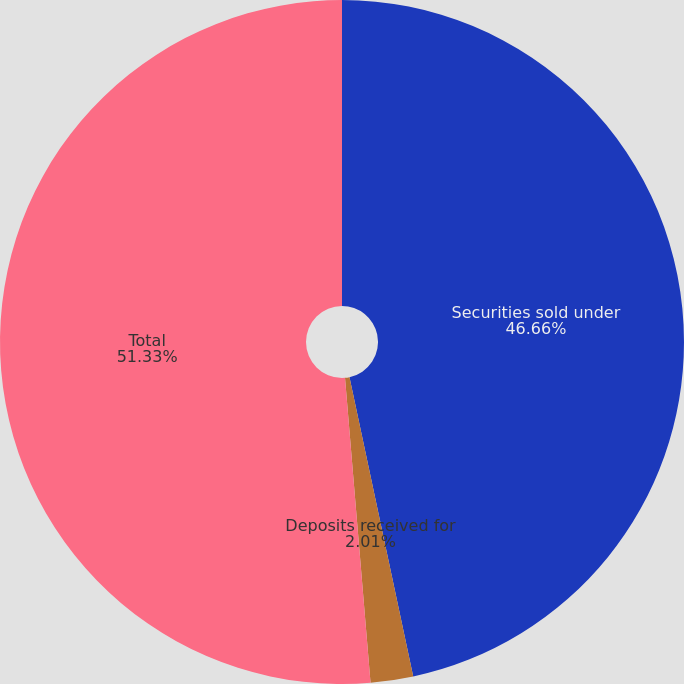Convert chart. <chart><loc_0><loc_0><loc_500><loc_500><pie_chart><fcel>Securities sold under<fcel>Deposits received for<fcel>Total<nl><fcel>46.66%<fcel>2.01%<fcel>51.33%<nl></chart> 